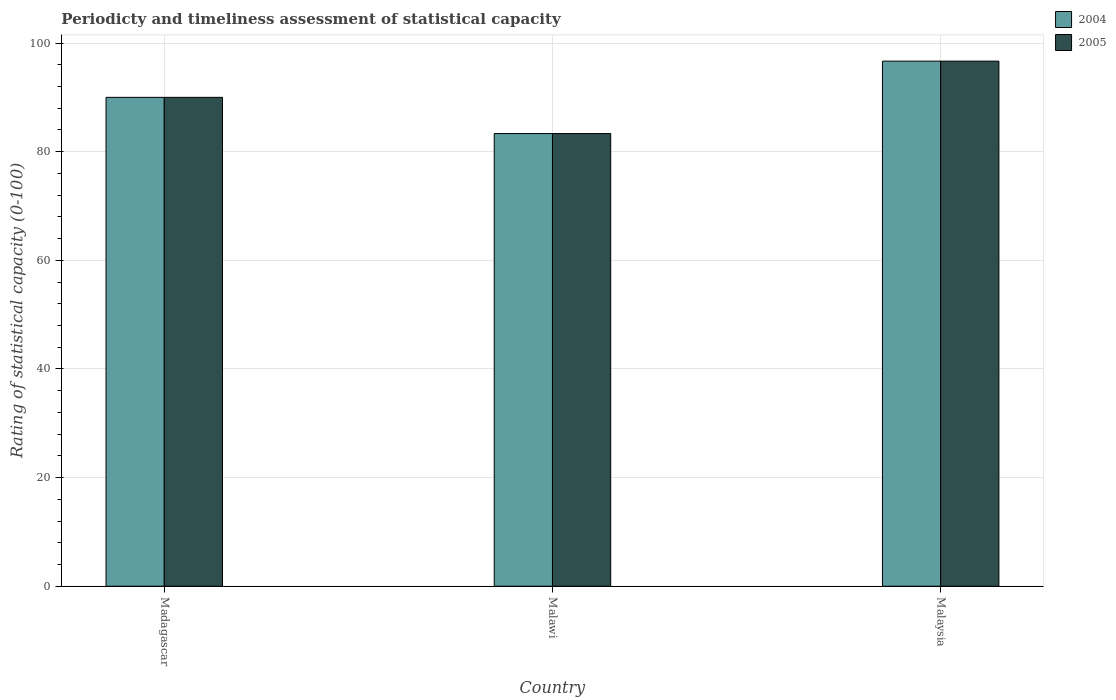Are the number of bars per tick equal to the number of legend labels?
Give a very brief answer. Yes. Are the number of bars on each tick of the X-axis equal?
Your answer should be very brief. Yes. What is the label of the 3rd group of bars from the left?
Keep it short and to the point. Malaysia. In how many cases, is the number of bars for a given country not equal to the number of legend labels?
Make the answer very short. 0. What is the rating of statistical capacity in 2004 in Malaysia?
Ensure brevity in your answer.  96.67. Across all countries, what is the maximum rating of statistical capacity in 2005?
Give a very brief answer. 96.67. Across all countries, what is the minimum rating of statistical capacity in 2005?
Your answer should be very brief. 83.33. In which country was the rating of statistical capacity in 2005 maximum?
Your answer should be compact. Malaysia. In which country was the rating of statistical capacity in 2005 minimum?
Your answer should be very brief. Malawi. What is the total rating of statistical capacity in 2005 in the graph?
Make the answer very short. 270. What is the difference between the rating of statistical capacity in 2005 in Madagascar and that in Malaysia?
Your answer should be compact. -6.67. What is the difference between the rating of statistical capacity in 2005 in Malawi and the rating of statistical capacity in 2004 in Malaysia?
Make the answer very short. -13.33. What is the difference between the rating of statistical capacity of/in 2005 and rating of statistical capacity of/in 2004 in Malaysia?
Provide a short and direct response. 0. In how many countries, is the rating of statistical capacity in 2004 greater than 92?
Ensure brevity in your answer.  1. What is the ratio of the rating of statistical capacity in 2004 in Madagascar to that in Malawi?
Your answer should be very brief. 1.08. What is the difference between the highest and the second highest rating of statistical capacity in 2004?
Offer a very short reply. 6.67. What is the difference between the highest and the lowest rating of statistical capacity in 2004?
Your answer should be very brief. 13.33. In how many countries, is the rating of statistical capacity in 2005 greater than the average rating of statistical capacity in 2005 taken over all countries?
Provide a succinct answer. 1. What does the 2nd bar from the left in Madagascar represents?
Provide a succinct answer. 2005. Are all the bars in the graph horizontal?
Your answer should be compact. No. What is the difference between two consecutive major ticks on the Y-axis?
Ensure brevity in your answer.  20. Are the values on the major ticks of Y-axis written in scientific E-notation?
Offer a very short reply. No. Does the graph contain any zero values?
Offer a terse response. No. Does the graph contain grids?
Ensure brevity in your answer.  Yes. Where does the legend appear in the graph?
Your response must be concise. Top right. How are the legend labels stacked?
Your answer should be very brief. Vertical. What is the title of the graph?
Offer a terse response. Periodicty and timeliness assessment of statistical capacity. What is the label or title of the Y-axis?
Offer a terse response. Rating of statistical capacity (0-100). What is the Rating of statistical capacity (0-100) of 2004 in Malawi?
Offer a terse response. 83.33. What is the Rating of statistical capacity (0-100) in 2005 in Malawi?
Keep it short and to the point. 83.33. What is the Rating of statistical capacity (0-100) of 2004 in Malaysia?
Your answer should be very brief. 96.67. What is the Rating of statistical capacity (0-100) in 2005 in Malaysia?
Provide a succinct answer. 96.67. Across all countries, what is the maximum Rating of statistical capacity (0-100) in 2004?
Ensure brevity in your answer.  96.67. Across all countries, what is the maximum Rating of statistical capacity (0-100) in 2005?
Provide a short and direct response. 96.67. Across all countries, what is the minimum Rating of statistical capacity (0-100) in 2004?
Provide a short and direct response. 83.33. Across all countries, what is the minimum Rating of statistical capacity (0-100) of 2005?
Make the answer very short. 83.33. What is the total Rating of statistical capacity (0-100) in 2004 in the graph?
Offer a terse response. 270. What is the total Rating of statistical capacity (0-100) in 2005 in the graph?
Your answer should be compact. 270. What is the difference between the Rating of statistical capacity (0-100) in 2004 in Madagascar and that in Malawi?
Provide a short and direct response. 6.67. What is the difference between the Rating of statistical capacity (0-100) of 2005 in Madagascar and that in Malawi?
Provide a succinct answer. 6.67. What is the difference between the Rating of statistical capacity (0-100) of 2004 in Madagascar and that in Malaysia?
Make the answer very short. -6.67. What is the difference between the Rating of statistical capacity (0-100) in 2005 in Madagascar and that in Malaysia?
Your answer should be compact. -6.67. What is the difference between the Rating of statistical capacity (0-100) of 2004 in Malawi and that in Malaysia?
Your answer should be compact. -13.33. What is the difference between the Rating of statistical capacity (0-100) of 2005 in Malawi and that in Malaysia?
Your answer should be very brief. -13.33. What is the difference between the Rating of statistical capacity (0-100) in 2004 in Madagascar and the Rating of statistical capacity (0-100) in 2005 in Malaysia?
Ensure brevity in your answer.  -6.67. What is the difference between the Rating of statistical capacity (0-100) in 2004 in Malawi and the Rating of statistical capacity (0-100) in 2005 in Malaysia?
Offer a terse response. -13.33. What is the average Rating of statistical capacity (0-100) in 2004 per country?
Give a very brief answer. 90. What is the average Rating of statistical capacity (0-100) of 2005 per country?
Provide a short and direct response. 90. What is the difference between the Rating of statistical capacity (0-100) of 2004 and Rating of statistical capacity (0-100) of 2005 in Malawi?
Provide a short and direct response. 0. What is the ratio of the Rating of statistical capacity (0-100) in 2004 in Madagascar to that in Malawi?
Offer a terse response. 1.08. What is the ratio of the Rating of statistical capacity (0-100) of 2004 in Madagascar to that in Malaysia?
Give a very brief answer. 0.93. What is the ratio of the Rating of statistical capacity (0-100) of 2005 in Madagascar to that in Malaysia?
Your answer should be compact. 0.93. What is the ratio of the Rating of statistical capacity (0-100) in 2004 in Malawi to that in Malaysia?
Your response must be concise. 0.86. What is the ratio of the Rating of statistical capacity (0-100) in 2005 in Malawi to that in Malaysia?
Your answer should be compact. 0.86. What is the difference between the highest and the second highest Rating of statistical capacity (0-100) of 2004?
Your response must be concise. 6.67. What is the difference between the highest and the lowest Rating of statistical capacity (0-100) of 2004?
Ensure brevity in your answer.  13.33. What is the difference between the highest and the lowest Rating of statistical capacity (0-100) of 2005?
Your response must be concise. 13.33. 